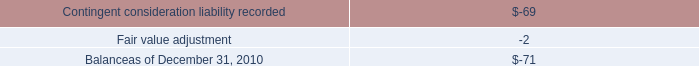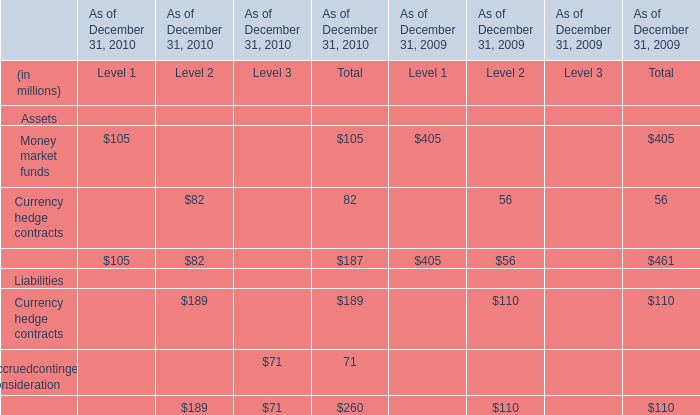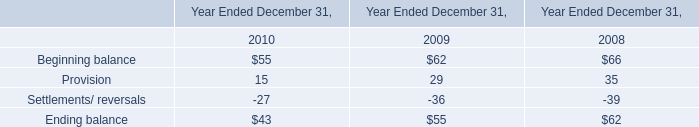What will Total of Currency hedge contracts reach in 2011 if it continues to grow at its 2010 rate? (in million) 
Computations: (189 * (1 + ((189 - 110) / 110)))
Answer: 324.73636. 